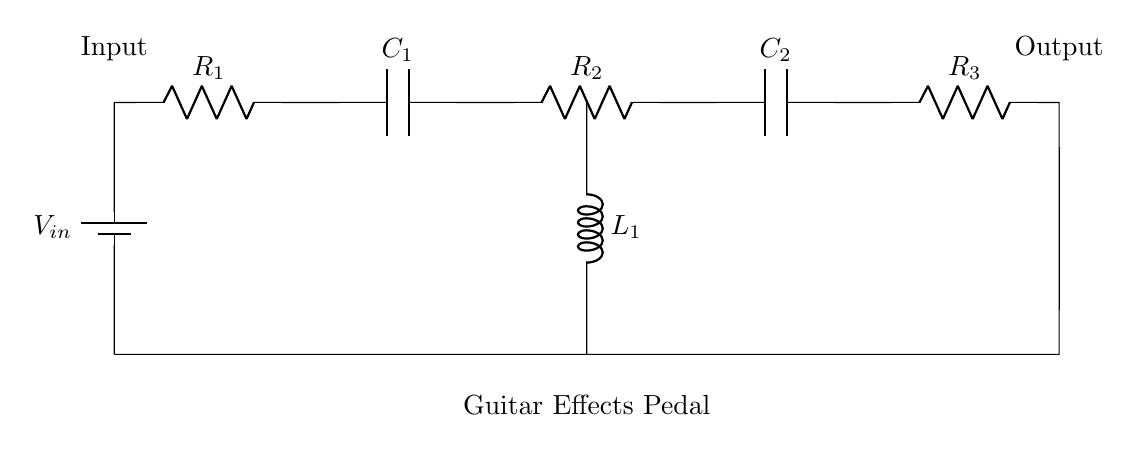What type of circuit is this? This is a series circuit, where all components are connected in a single pathway. Current flows through each component sequentially without any branching.
Answer: series circuit How many resistors are in the circuit? The circuit contains three resistors, which are labeled as R1, R2, and R3. They are connected in series with the other components.
Answer: three What is the purpose of the capacitors in this circuit? The capacitors, C1 and C2, store and release electrical energy, helping to filter signals and affect the frequency response of the circuit.
Answer: filtering What component connects inductor L1 to the circuit? The inductor L1 is connected to the circuit through a straight vertical line from the capacitor C1. This allows current to flow through the inductor, affecting the overall circuit behavior.
Answer: a vertical connection Which component would likely affect the output signal the most? The resistors R1, R2, and R3 will directly affect the voltage and current at the output due to their role in limiting current and dropping voltage in the series configuration.
Answer: resistors What happens to the total resistance if R1 is removed? If R1 is removed, the total resistance decreases, making it easier for current to flow through the circuit as fewer resistances are present in series.
Answer: it decreases What is the effect of adding more capacitors in series? Adding more capacitors in series reduces the total capacitance, which affects the timing and filtering characteristics of the circuit.
Answer: total capacitance decreases 